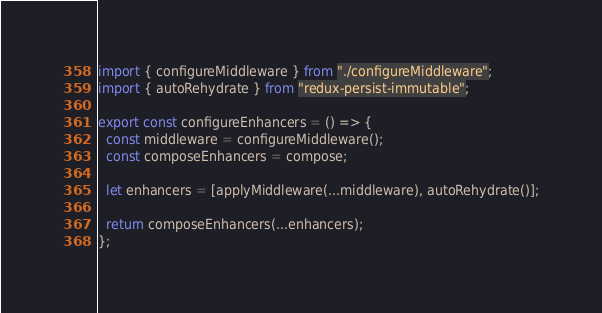<code> <loc_0><loc_0><loc_500><loc_500><_JavaScript_>import { configureMiddleware } from "./configureMiddleware";
import { autoRehydrate } from "redux-persist-immutable";

export const configureEnhancers = () => {
  const middleware = configureMiddleware();
  const composeEnhancers = compose;

  let enhancers = [applyMiddleware(...middleware), autoRehydrate()];

  return composeEnhancers(...enhancers);
};
</code> 